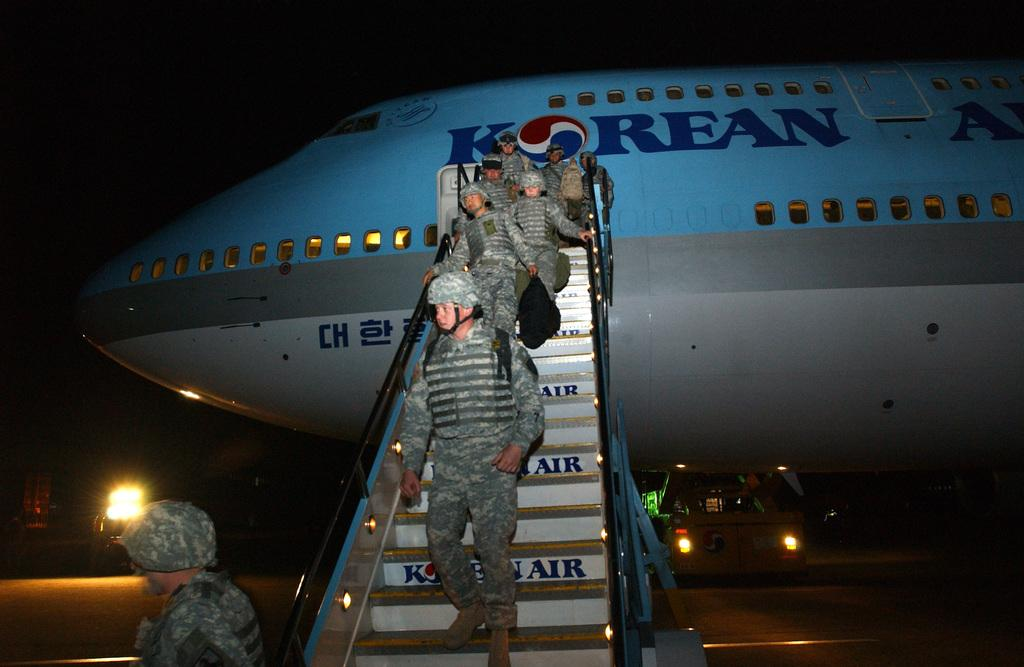What is the main subject of the picture? The main subject of the picture is an airplane. Are there any people in the picture? Yes, there are people in the picture. What else can be seen on the ground in the picture? There are vehicles on the ground in the picture. How would you describe the background of the picture? The background of the picture appears to be dark. Can you see any cobwebs in the picture? There are no cobwebs present in the image, as it features an airplane, people, and vehicles on the ground. What type of adjustment is being made to the airplane in the picture? There is no adjustment being made to the airplane in the picture; it is simply depicted in the scene. 